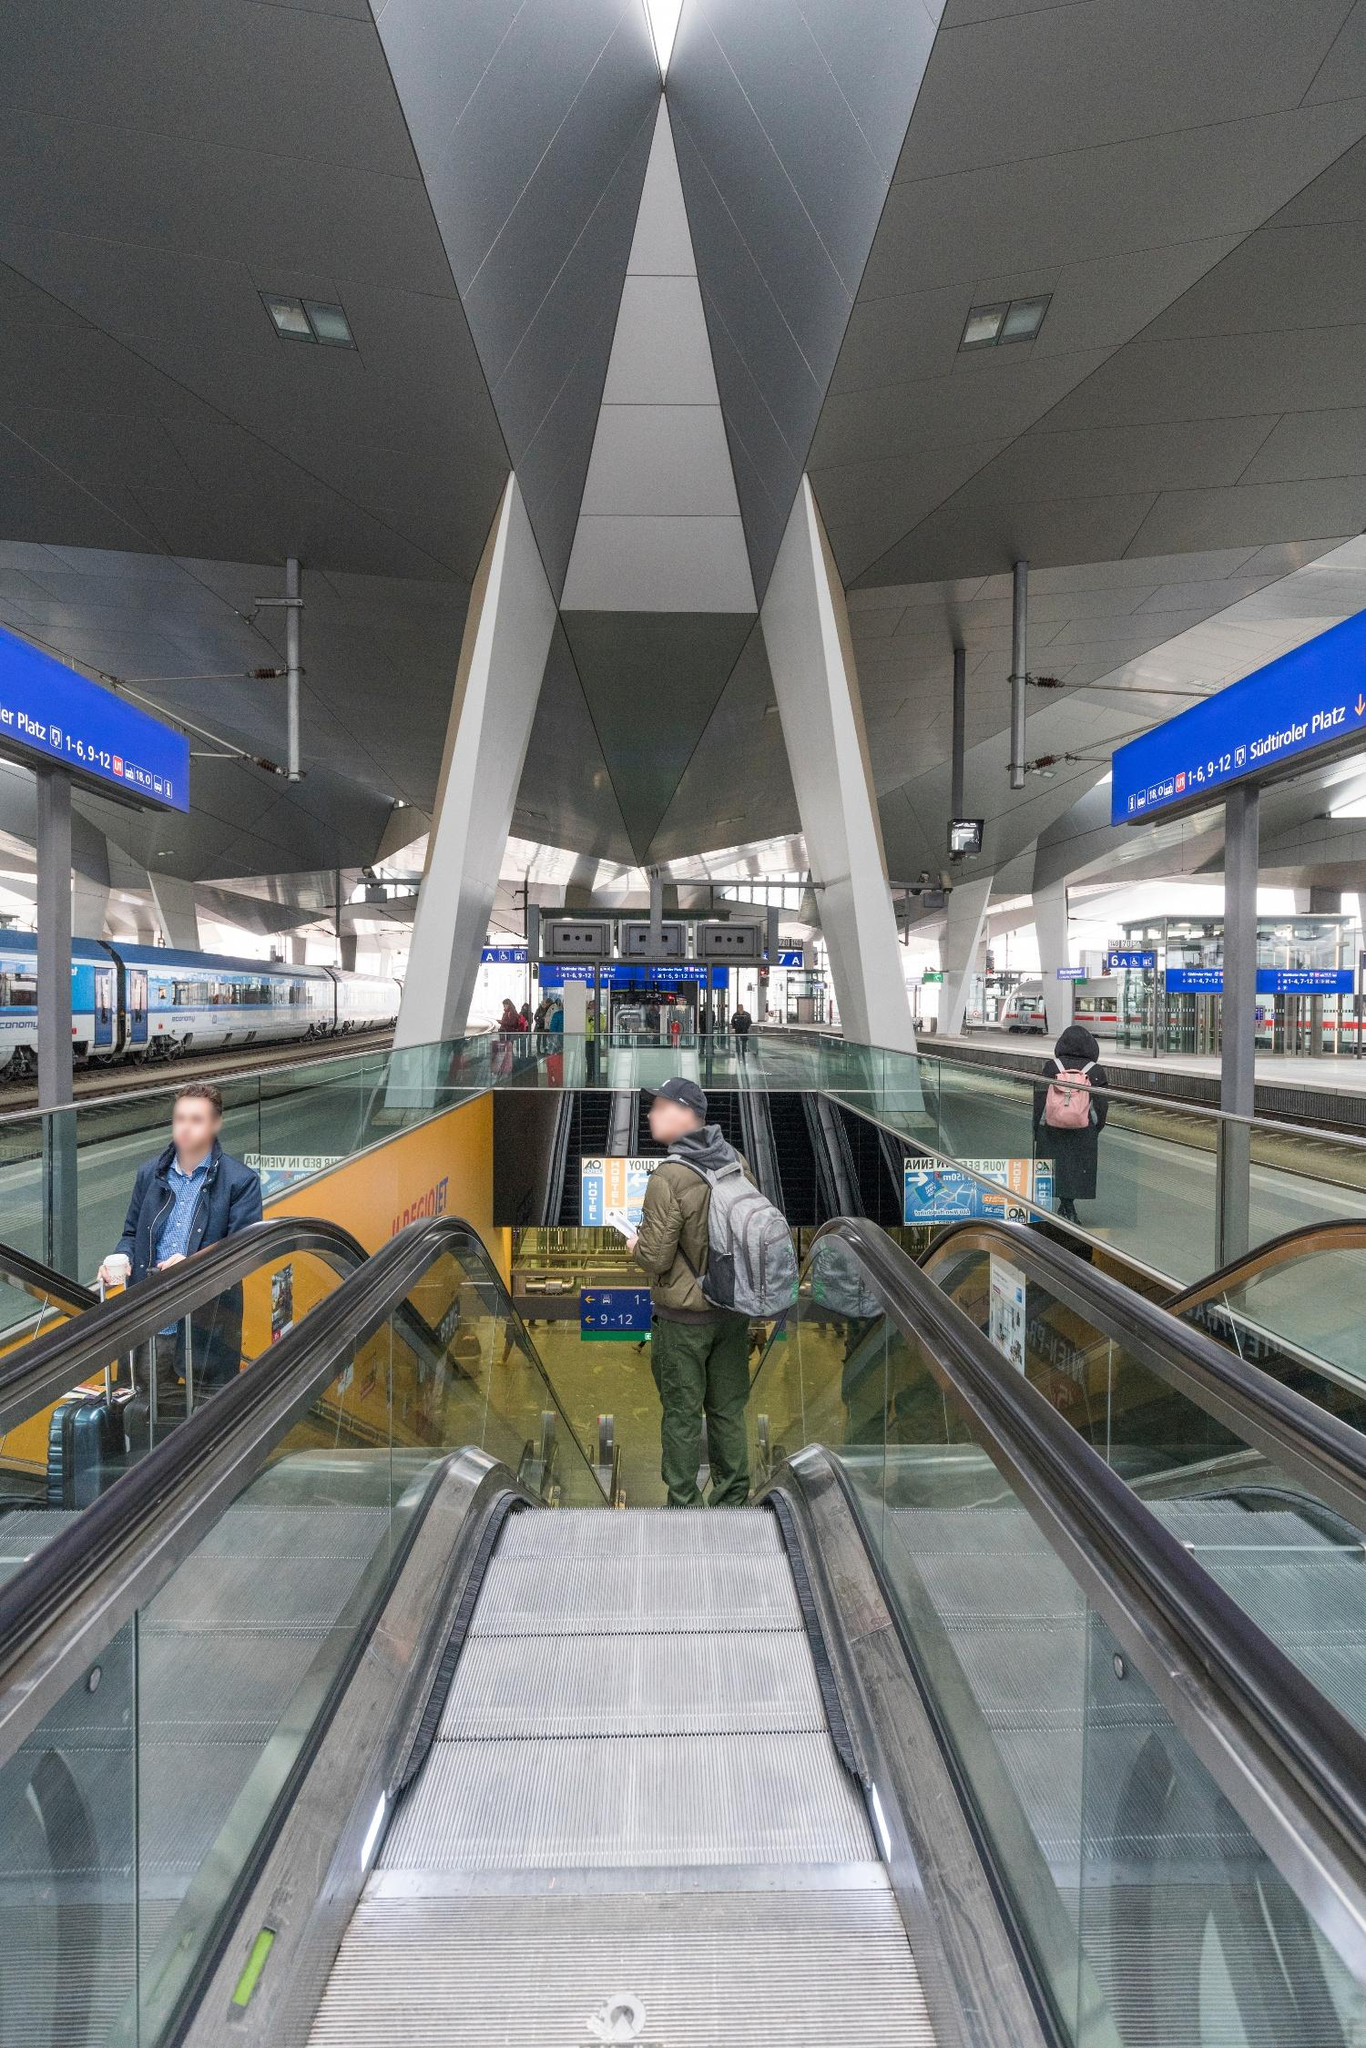What is this photo about? This photo vividly captures the dynamic environment of a contemporary urban train station, specifically viewed from an escalator leading down to several platforms. The stark geometric shapes of the station's architecture, particularly the sharp triangular pillars framing the escalator, provide a sense of modernity and functional design. Illuminated signs in blue indicate station platforms and directions, reinforcing the station's role as a navigational hub for commuters. The people in the image, though few, add a human element to the scene, hinting at the daily flow of passengers who pass through this transit space. Each element, from the metallic sheen of the pillars to the blur of a moving escalator, combines to illustrate not just the physical space but also the quiet buzz of activity typical of public transport areas. 